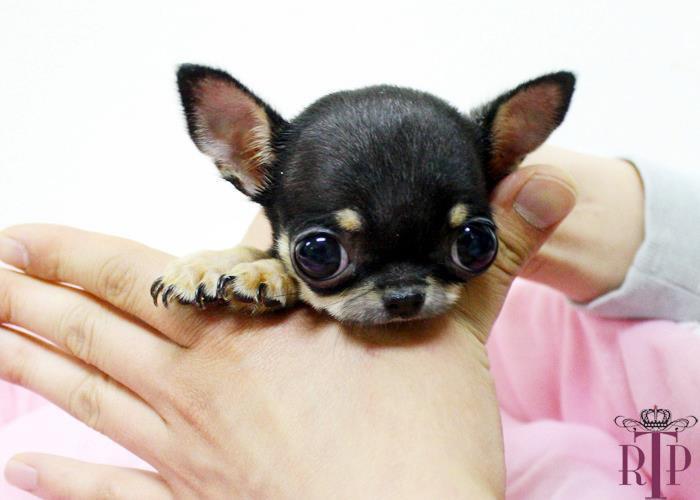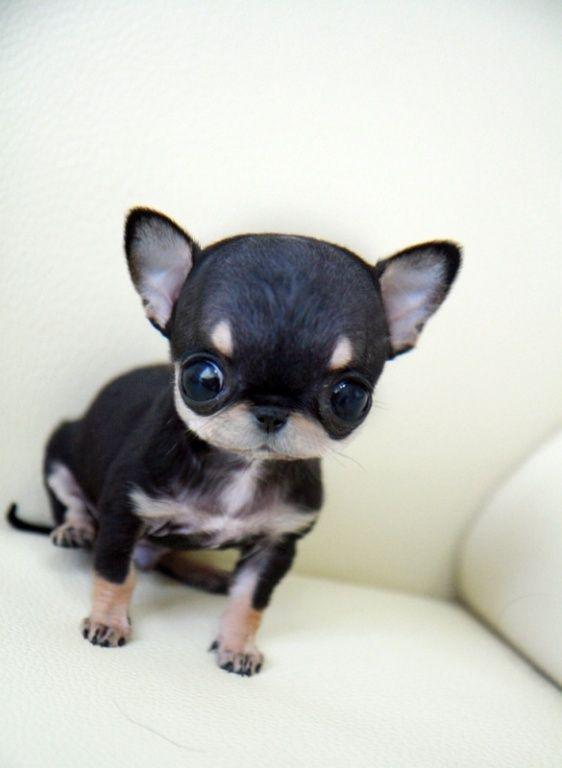The first image is the image on the left, the second image is the image on the right. Analyze the images presented: Is the assertion "At least one animal is drinking milk." valid? Answer yes or no. No. The first image is the image on the left, the second image is the image on the right. For the images shown, is this caption "There are two chihuahua puppies." true? Answer yes or no. Yes. 